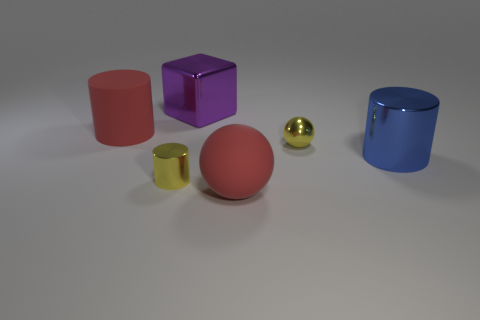There is a object that is the same color as the small ball; what is its shape?
Make the answer very short. Cylinder. There is a thing that is both on the left side of the purple shiny block and in front of the tiny ball; what is it made of?
Provide a succinct answer. Metal. How many other objects are the same size as the blue cylinder?
Your answer should be very brief. 3. There is a shiny object that is behind the big matte thing behind the big sphere; are there any big red cylinders in front of it?
Your answer should be very brief. Yes. Is the material of the tiny yellow thing that is on the left side of the big metallic block the same as the large blue cylinder?
Provide a short and direct response. Yes. There is another small object that is the same shape as the blue object; what is its color?
Provide a short and direct response. Yellow. Is there any other thing that has the same shape as the purple metallic object?
Your answer should be compact. No. Are there the same number of large red objects that are behind the yellow cylinder and tiny yellow metal cylinders?
Your answer should be very brief. Yes. Are there any metallic balls in front of the large purple cube?
Keep it short and to the point. Yes. There is a yellow cylinder left of the big cylinder that is in front of the tiny thing on the right side of the big purple object; how big is it?
Your answer should be very brief. Small. 